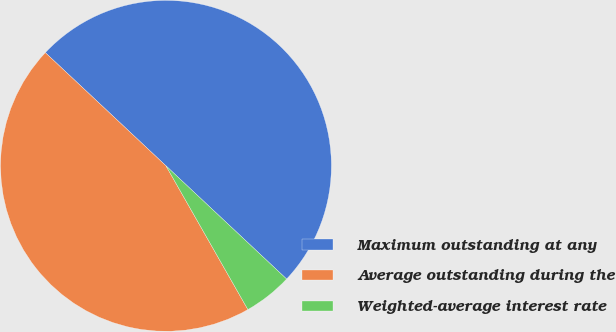Convert chart. <chart><loc_0><loc_0><loc_500><loc_500><pie_chart><fcel>Maximum outstanding at any<fcel>Average outstanding during the<fcel>Weighted-average interest rate<nl><fcel>50.0%<fcel>45.24%<fcel>4.76%<nl></chart> 